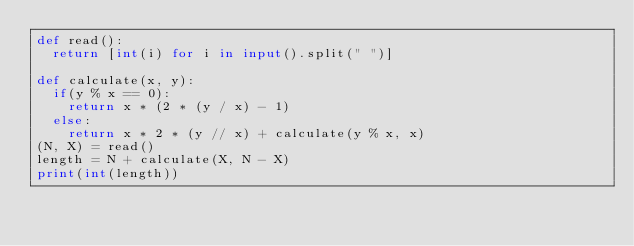<code> <loc_0><loc_0><loc_500><loc_500><_Python_>def read():
	return [int(i) for i in input().split(" ")]

def calculate(x, y):
	if(y % x == 0):
		return x * (2 * (y / x) - 1) 
	else:
		return x * 2 * (y // x) + calculate(y % x, x) 
(N, X) = read()
length = N + calculate(X, N - X)
print(int(length))</code> 